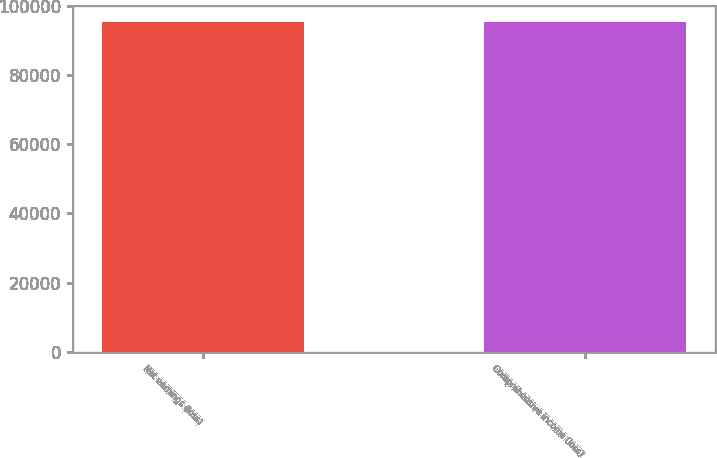Convert chart. <chart><loc_0><loc_0><loc_500><loc_500><bar_chart><fcel>Net earnings (loss)<fcel>Comprehensive income (loss)<nl><fcel>95261<fcel>95261.1<nl></chart> 